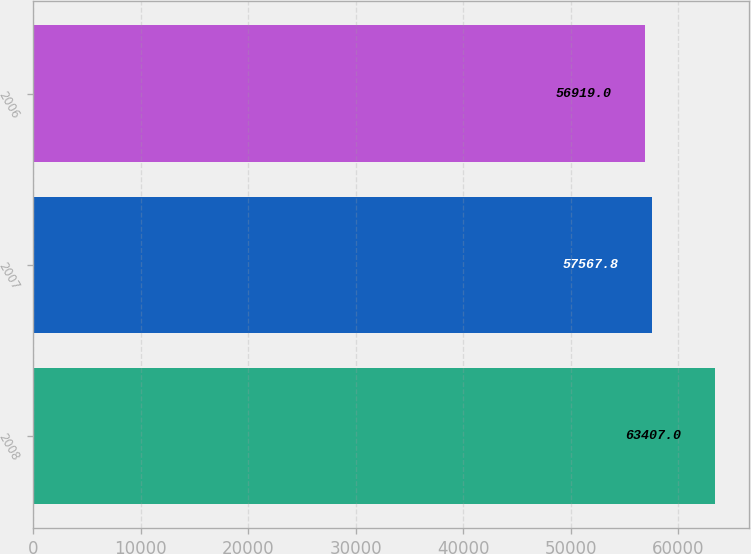Convert chart to OTSL. <chart><loc_0><loc_0><loc_500><loc_500><bar_chart><fcel>2008<fcel>2007<fcel>2006<nl><fcel>63407<fcel>57567.8<fcel>56919<nl></chart> 